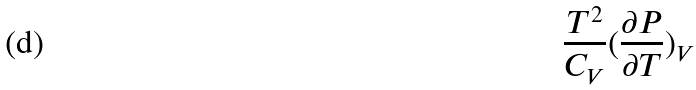Convert formula to latex. <formula><loc_0><loc_0><loc_500><loc_500>\frac { T ^ { 2 } } { C _ { V } } ( \frac { \partial P } { \partial T } ) _ { V }</formula> 